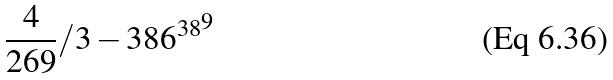Convert formula to latex. <formula><loc_0><loc_0><loc_500><loc_500>\frac { 4 } { 2 6 9 } / 3 - { 3 8 6 ^ { 3 8 } } ^ { 9 }</formula> 